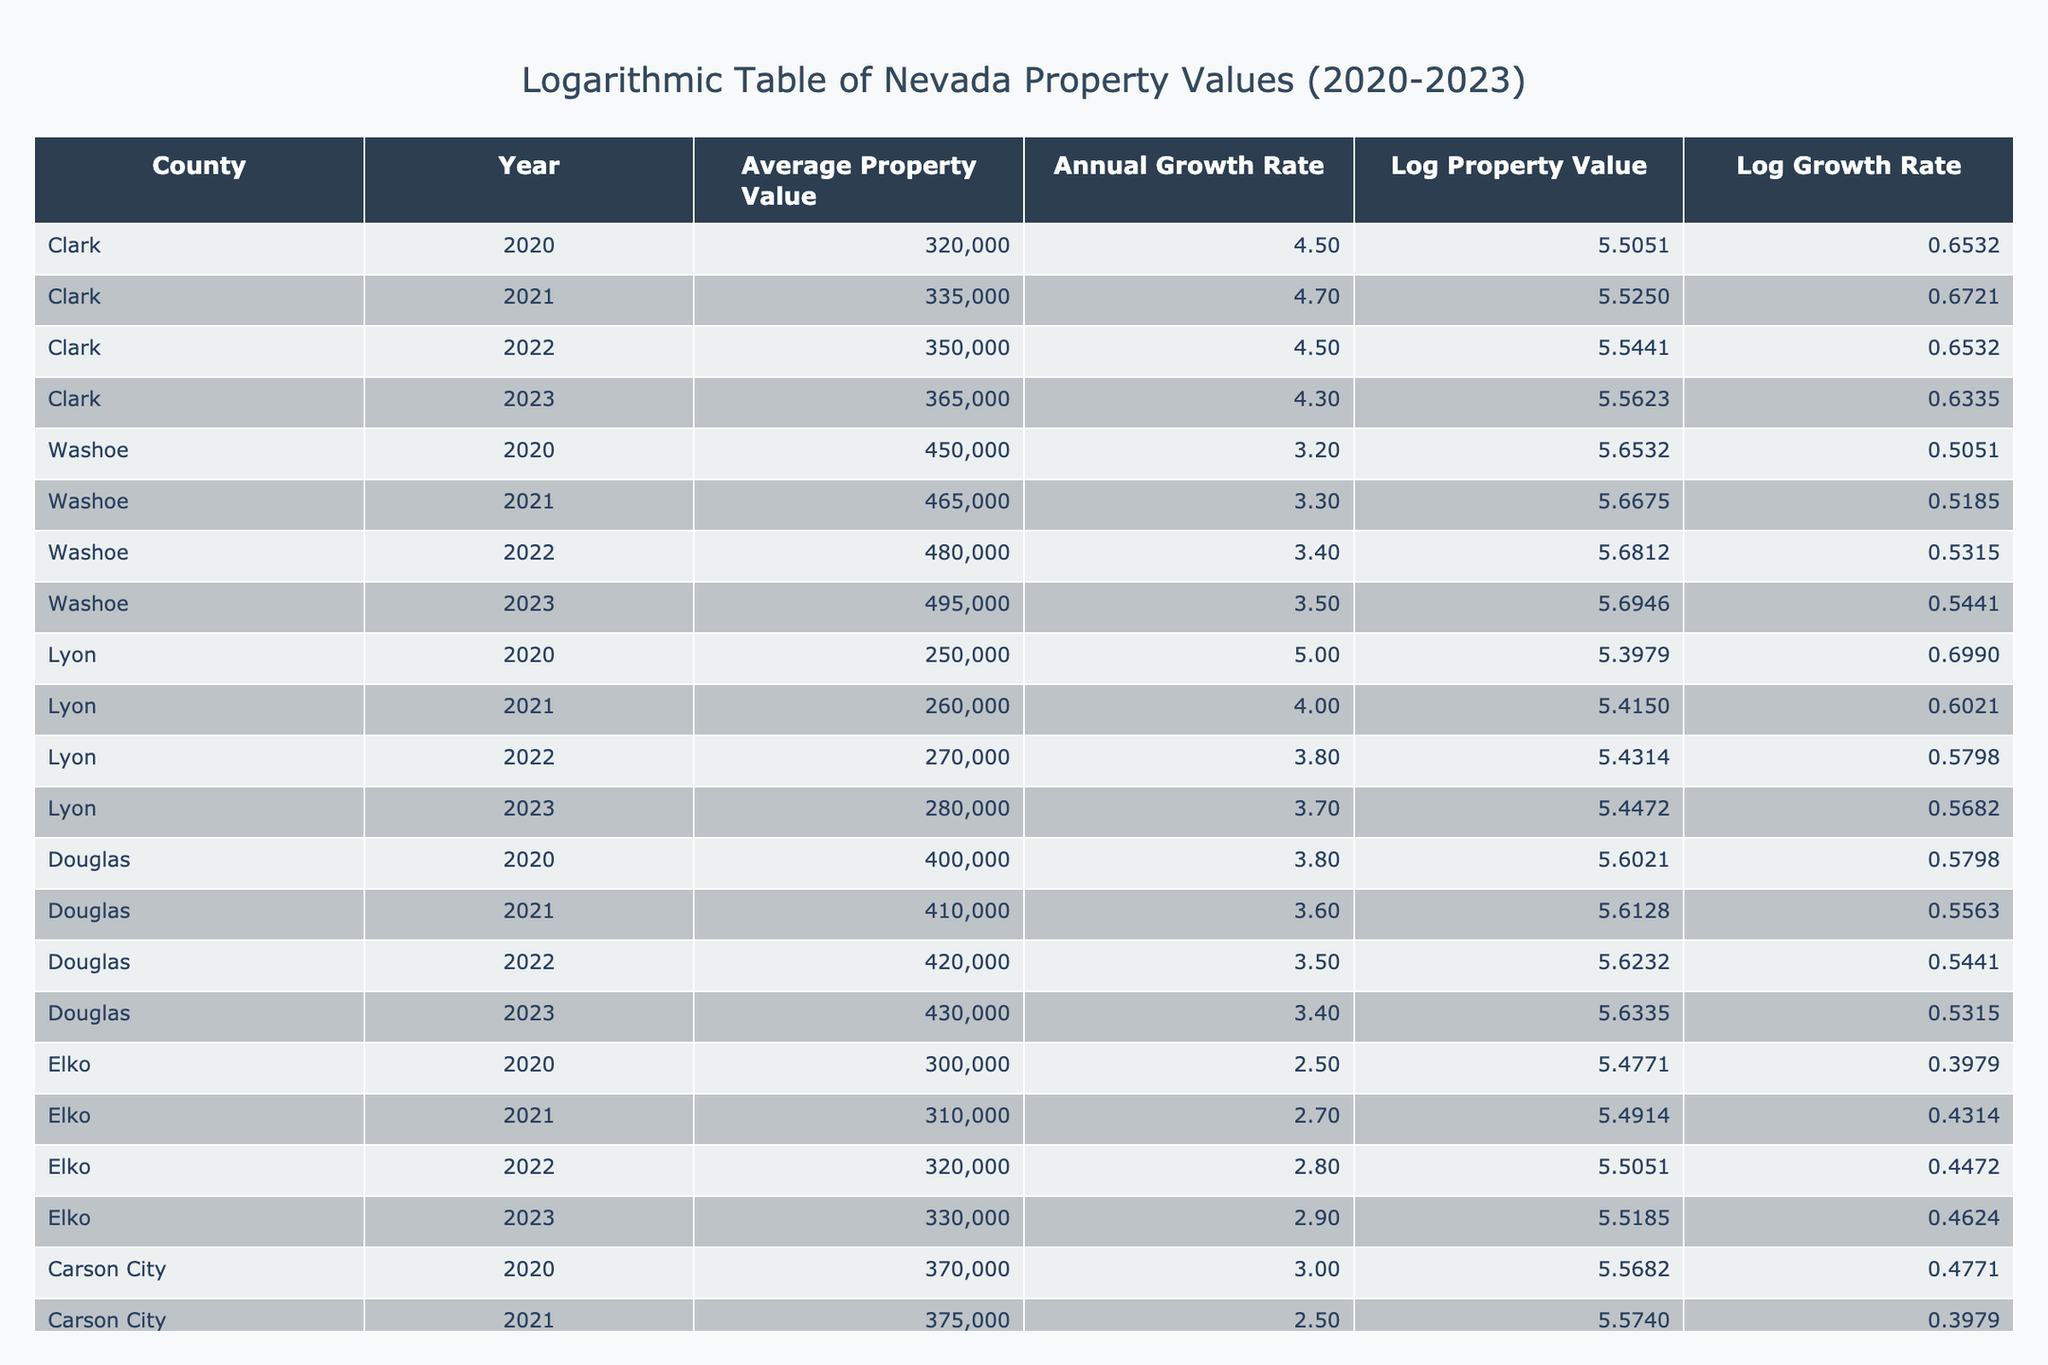What was the Average Property Value in Clark County in 2021? Looking at the table, we see that in the row for Clark County and the year 2021, the Average Property Value is listed as 335,000.
Answer: 335000 Which county had the highest Average Property Value in 2023? From the table, we can see the Average Property Values for 2023: Clark has 365,000, Washoe has 495,000, Lyon has 280,000, Douglas has 430,000, and Elko has 330,000. Washoe has the highest value at 495,000.
Answer: Washoe What is the Annual Growth Rate of Lyon County in 2022? The table shows that for Lyon County in 2022, the Annual Growth Rate is 3.8.
Answer: 3.8 What is the average Annual Growth Rate for all counties from 2020 to 2023? To find the average Annual Growth Rate, we sum the values: 4.5 (Clark 2020) + 4.7 (Clark 2021) + 4.5 (Clark 2022) + 4.3 (Clark 2023) + 3.2 (Washoe 2020) + 3.3 (Washoe 2021) + 3.4 (Washoe 2022) + 3.5 (Washoe 2023) + 5.0 (Lyon 2020) + 4.0 (Lyon 2021) + 3.8 (Lyon 2022) + 3.7 (Lyon 2023) + 3.8 (Douglas 2020) + 3.6 (Douglas 2021) + 3.5 (Douglas 2022) + 3.4 (Douglas 2023) + 2.5 (Elko 2020) + 2.7 (Elko 2021) + 2.8 (Elko 2022) + 2.9 (Elko 2023) + 3.0 (Carson City 2020) + 2.5 (Carson City 2021) + 2.7 (Carson City 2022) + 2.4 (Carson City 2023). Adding these gives 64.4. There are 24 total entries, so the average is 64.4 / 24 = 2.6833, approximately 2.68 when rounded.
Answer: 2.68 Did the Average Property Value in Carson City increase every year from 2020 to 2023? The table indicates the Average Property Values for Carson City over the years as follows: 370,000 (2020), 375,000 (2021), 380,000 (2022), and 385,000 (2023). There is an increase each year, confirming that it did increase every year.
Answer: Yes Which county had the lowest Annual Growth Rate among all years? By reviewing the Annual Growth Rates from the table, we find: Clark has rates of 4.5, 4.7, 4.5, 4.3; Washoe has 3.2, 3.3, 3.4, 3.5; Lyon shows 5.0, 4.0, 3.8, 3.7; Douglas: 3.8, 3.6, 3.5, 3.4; Elko: 2.5, 2.7, 2.8, 2.9; Carson City has rates of 3.0, 2.5, 2.7, 2.4. The lowest rate presented is 2.4 from Carson City in 2023.
Answer: Carson City What was the change in Average Property Value for Washoe County from 2020 to 2023? For Washoe County, the Average Property Value in 2020 was 450,000 and in 2023 it is 495,000. The change in value is 495,000 - 450,000 = 45,000.
Answer: 45000 Which county saw a decrease in its Annual Growth Rate from 2020 to 2023? Comparing each county's Annual Growth Rates, we see: Clark starts at 4.5 (2020) and decreases to 4.3 (2023), Washoe decreases from 3.2 to 3.5 but is overall an increase, Lyon decreases from 5.0 to 3.7. Douglas goes from 3.8 to 3.4, Elko from 2.5 to 2.9 is an increase, while Carson City goes from 3.0 to 2.4, confirming Clark, Lyon, Douglas, and Carson City had decreases.
Answer: Yes 